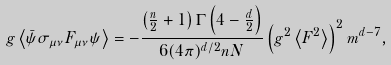<formula> <loc_0><loc_0><loc_500><loc_500>g \left < \bar { \psi } \sigma _ { \mu \nu } F _ { \mu \nu } \psi \right > = - \frac { \left ( \frac { n } { 2 } + 1 \right ) \Gamma \left ( 4 - \frac { d } { 2 } \right ) } { 6 ( 4 \pi ) ^ { d / 2 } n N } \left ( g ^ { 2 } \left < F ^ { 2 } \right > \right ) ^ { 2 } m ^ { d - 7 } ,</formula> 